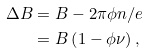<formula> <loc_0><loc_0><loc_500><loc_500>\Delta B & = B - 2 \pi \phi n / e \\ & = B \left ( 1 - \phi \nu \right ) ,</formula> 